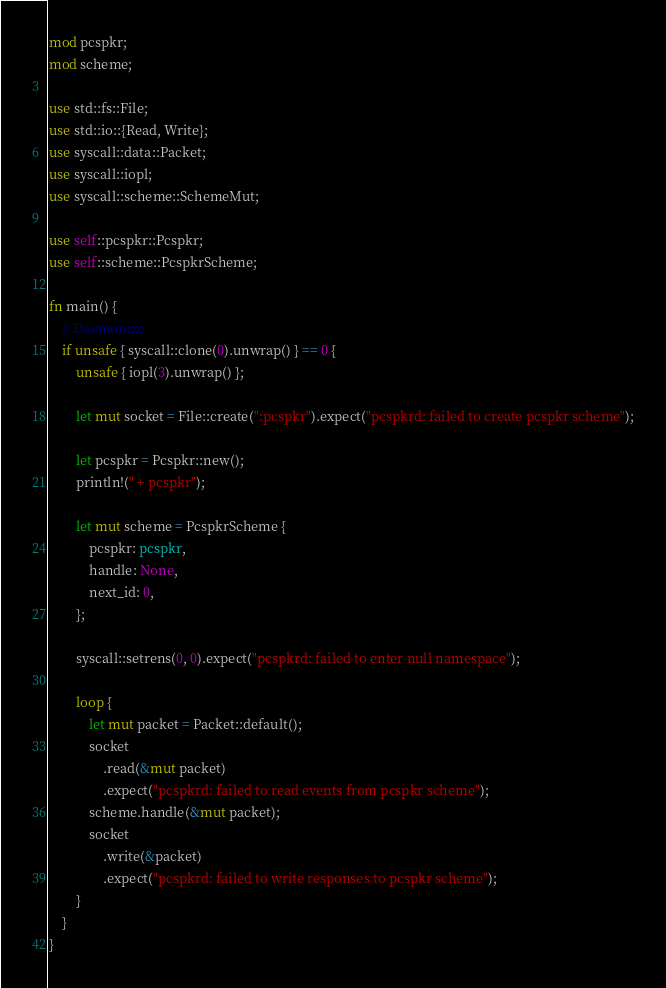Convert code to text. <code><loc_0><loc_0><loc_500><loc_500><_Rust_>mod pcspkr;
mod scheme;

use std::fs::File;
use std::io::{Read, Write};
use syscall::data::Packet;
use syscall::iopl;
use syscall::scheme::SchemeMut;

use self::pcspkr::Pcspkr;
use self::scheme::PcspkrScheme;

fn main() {
    // Daemonize
    if unsafe { syscall::clone(0).unwrap() } == 0 {
        unsafe { iopl(3).unwrap() };

        let mut socket = File::create(":pcspkr").expect("pcspkrd: failed to create pcspkr scheme");

        let pcspkr = Pcspkr::new();
        println!(" + pcspkr");

        let mut scheme = PcspkrScheme {
            pcspkr: pcspkr,
            handle: None,
            next_id: 0,
        };

        syscall::setrens(0, 0).expect("pcspkrd: failed to enter null namespace");

        loop {
            let mut packet = Packet::default();
            socket
                .read(&mut packet)
                .expect("pcspkrd: failed to read events from pcspkr scheme");
            scheme.handle(&mut packet);
            socket
                .write(&packet)
                .expect("pcspkrd: failed to write responses to pcspkr scheme");
        }
    }
}
</code> 